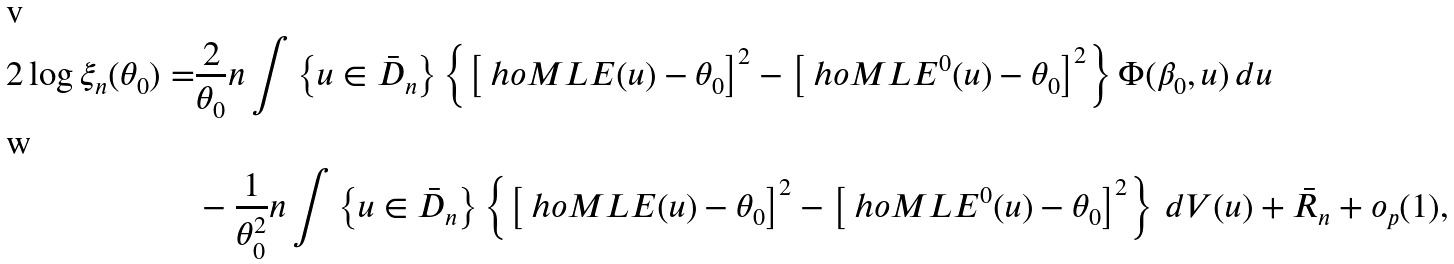Convert formula to latex. <formula><loc_0><loc_0><loc_500><loc_500>2 \log \xi _ { n } ( \theta _ { 0 } ) = & \frac { 2 } { \theta _ { 0 } } n \int \left \{ u \in \bar { D } _ { n } \right \} \left \{ \left [ \ h o M L E ( u ) - \theta _ { 0 } \right ] ^ { 2 } - \left [ \ h o M L E ^ { 0 } ( u ) - \theta _ { 0 } \right ] ^ { 2 } \right \} \Phi ( \beta _ { 0 } , u ) \, d u \\ & - \frac { 1 } { \theta _ { 0 } ^ { 2 } } n \int \left \{ u \in \bar { D } _ { n } \right \} \left \{ \left [ \ h o M L E ( u ) - \theta _ { 0 } \right ] ^ { 2 } - \left [ \ h o M L E ^ { 0 } ( u ) - \theta _ { 0 } \right ] ^ { 2 } \right \} \, d V ( u ) + \bar { R } _ { n } + o _ { p } ( 1 ) ,</formula> 